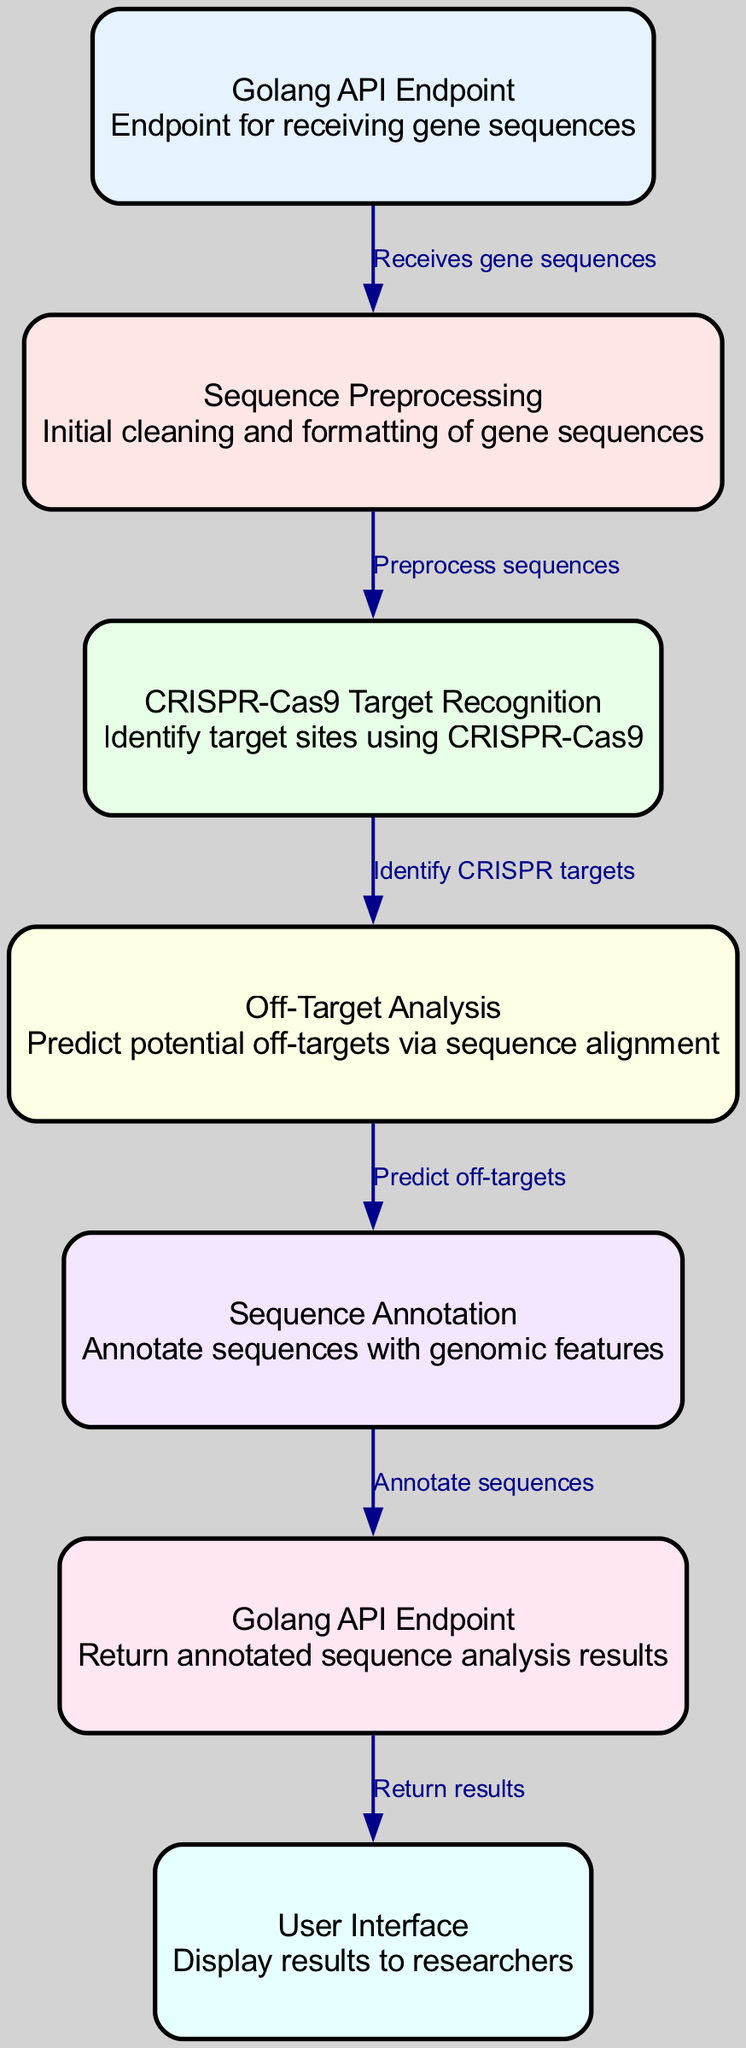What is the first processing step for gene sequences? The first processing step according to the diagram is "Sequence Preprocessing," which follows the "Golang API Endpoint" that receives the gene sequences.
Answer: Sequence Preprocessing How many nodes are present in the diagram? The diagram contains a total of seven nodes, each representing a specific part of the data flow in the CRISPR gene editing process.
Answer: 7 What does the "Off-Target Analysis" node analyze? The "Off-Target Analysis" node predicts potential off-targets by performing sequence alignment based on the previously identified CRISPR target sites.
Answer: Potential off-targets What relationship does the "Sequence Annotation" node have with the "Golang API Endpoint" node? The "Sequence Annotation" node annotates sequences with genomic features and this information is sent to the "Golang API Endpoint" that returns results to the user interface.
Answer: Annotate sequences Which node receives the results to be displayed to researchers? The results from the "Golang API Endpoint" are sent to the "User Interface," which is responsible for displaying them to researchers.
Answer: User Interface What is the primary function of the "CRISPR-Cas9 Target Recognition" node? The function of the "CRISPR-Cas9 Target Recognition" node is to identify target sites using the CRISPR-Cas9 technology, making it integral to the gene editing process depicted in the diagram.
Answer: Identify target sites Which node follows "Sequence Preprocessing" in the data flow? Following "Sequence Preprocessing" in the data flow is the "CRISPR-Cas9 Target Recognition" node, indicating the next step in the analysis after preprocessing the gene sequences.
Answer: CRISPR-Cas9 Target Recognition Explain the flow from the first node to the last node in terms of the processing steps. The flow starts at the "Golang API Endpoint" which receives gene sequences, then it goes to "Sequence Preprocessing" for cleaning and formatting, followed by "CRISPR-Cas9 Target Recognition" to identify targets, leading to "Off-Target Analysis" for alignment predictions, then to "Sequence Annotation" for genomic feature annotations, before reaching the second "Golang API Endpoint" to return results to the "User Interface" for display.
Answer: Receives gene sequences, preprocesses, identifies targets, predicts off-targets, annotates sequences, returns results, displays to researchers 